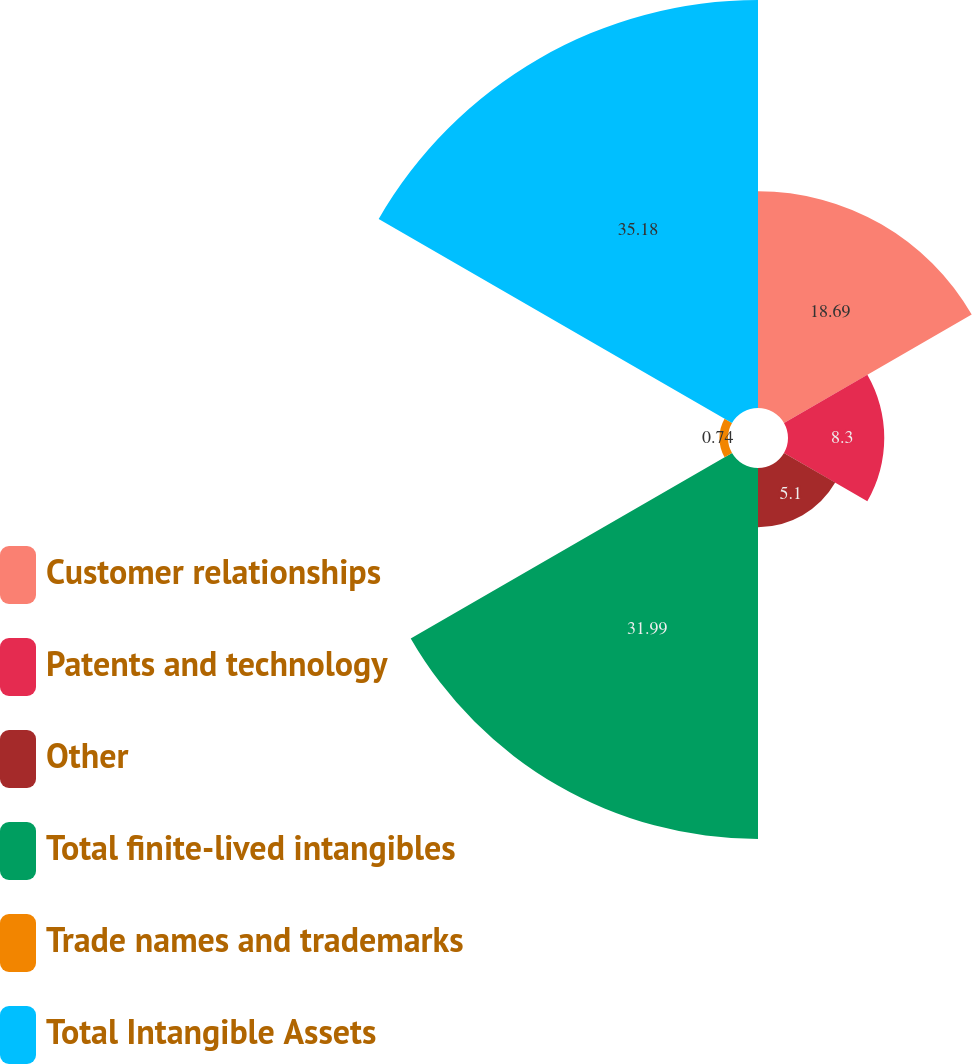<chart> <loc_0><loc_0><loc_500><loc_500><pie_chart><fcel>Customer relationships<fcel>Patents and technology<fcel>Other<fcel>Total finite-lived intangibles<fcel>Trade names and trademarks<fcel>Total Intangible Assets<nl><fcel>18.69%<fcel>8.3%<fcel>5.1%<fcel>31.99%<fcel>0.74%<fcel>35.18%<nl></chart> 